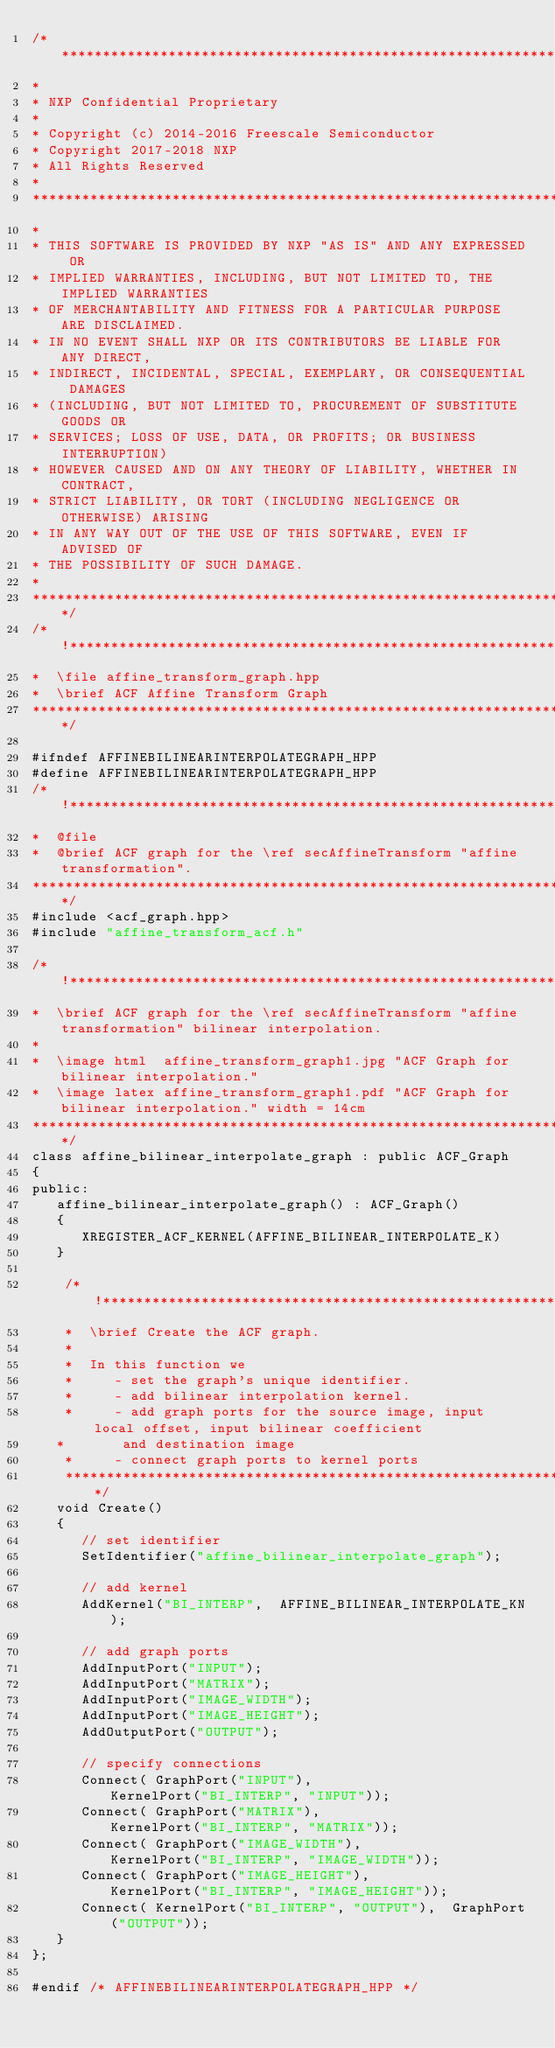<code> <loc_0><loc_0><loc_500><loc_500><_C++_>/*****************************************************************************
* 
* NXP Confidential Proprietary
*
* Copyright (c) 2014-2016 Freescale Semiconductor
* Copyright 2017-2018 NXP 
* All Rights Reserved
*
******************************************************************************
*
* THIS SOFTWARE IS PROVIDED BY NXP "AS IS" AND ANY EXPRESSED OR
* IMPLIED WARRANTIES, INCLUDING, BUT NOT LIMITED TO, THE IMPLIED WARRANTIES
* OF MERCHANTABILITY AND FITNESS FOR A PARTICULAR PURPOSE ARE DISCLAIMED.
* IN NO EVENT SHALL NXP OR ITS CONTRIBUTORS BE LIABLE FOR ANY DIRECT,
* INDIRECT, INCIDENTAL, SPECIAL, EXEMPLARY, OR CONSEQUENTIAL DAMAGES
* (INCLUDING, BUT NOT LIMITED TO, PROCUREMENT OF SUBSTITUTE GOODS OR
* SERVICES; LOSS OF USE, DATA, OR PROFITS; OR BUSINESS INTERRUPTION)
* HOWEVER CAUSED AND ON ANY THEORY OF LIABILITY, WHETHER IN CONTRACT,
* STRICT LIABILITY, OR TORT (INCLUDING NEGLIGENCE OR OTHERWISE) ARISING
* IN ANY WAY OUT OF THE USE OF THIS SOFTWARE, EVEN IF ADVISED OF
* THE POSSIBILITY OF SUCH DAMAGE.
*
****************************************************************************/
/*!*********************************************************************************
*  \file affine_transform_graph.hpp
*  \brief ACF Affine Transform Graph
***********************************************************************************/

#ifndef AFFINEBILINEARINTERPOLATEGRAPH_HPP
#define AFFINEBILINEARINTERPOLATEGRAPH_HPP
/*!*********************************************************************************
*  @file
*  @brief ACF graph for the \ref secAffineTransform "affine transformation".
***********************************************************************************/
#include <acf_graph.hpp>
#include "affine_transform_acf.h"

/*!*********************************************************************************
*  \brief ACF graph for the \ref secAffineTransform "affine transformation" bilinear interpolation.
*
*  \image html  affine_transform_graph1.jpg "ACF Graph for bilinear interpolation."
*  \image latex affine_transform_graph1.pdf "ACF Graph for bilinear interpolation." width = 14cm
***********************************************************************************/
class affine_bilinear_interpolate_graph : public ACF_Graph
{
public:
   affine_bilinear_interpolate_graph() : ACF_Graph()
   {
      XREGISTER_ACF_KERNEL(AFFINE_BILINEAR_INTERPOLATE_K)
   }

    /*!*********************************************************************************
    *  \brief Create the ACF graph.
    *
    *  In this function we
    *     - set the graph's unique identifier.
    *     - add bilinear interpolation kernel.
    *     - add graph ports for the source image, input local offset, input bilinear coefficient
   *       and destination image
    *     - connect graph ports to kernel ports
    ***********************************************************************************/
   void Create()
   {
      // set identifier
      SetIdentifier("affine_bilinear_interpolate_graph");
      
      // add kernel
      AddKernel("BI_INTERP",  AFFINE_BILINEAR_INTERPOLATE_KN);
      
      // add graph ports
      AddInputPort("INPUT");
      AddInputPort("MATRIX");
      AddInputPort("IMAGE_WIDTH");
      AddInputPort("IMAGE_HEIGHT");
      AddOutputPort("OUTPUT");
      
      // specify connections
      Connect( GraphPort("INPUT"),                 KernelPort("BI_INTERP", "INPUT"));
      Connect( GraphPort("MATRIX"),                KernelPort("BI_INTERP", "MATRIX"));
      Connect( GraphPort("IMAGE_WIDTH"),           KernelPort("BI_INTERP", "IMAGE_WIDTH"));
      Connect( GraphPort("IMAGE_HEIGHT"),          KernelPort("BI_INTERP", "IMAGE_HEIGHT"));
      Connect( KernelPort("BI_INTERP", "OUTPUT"),  GraphPort("OUTPUT"));
   }
};

#endif /* AFFINEBILINEARINTERPOLATEGRAPH_HPP */

</code> 